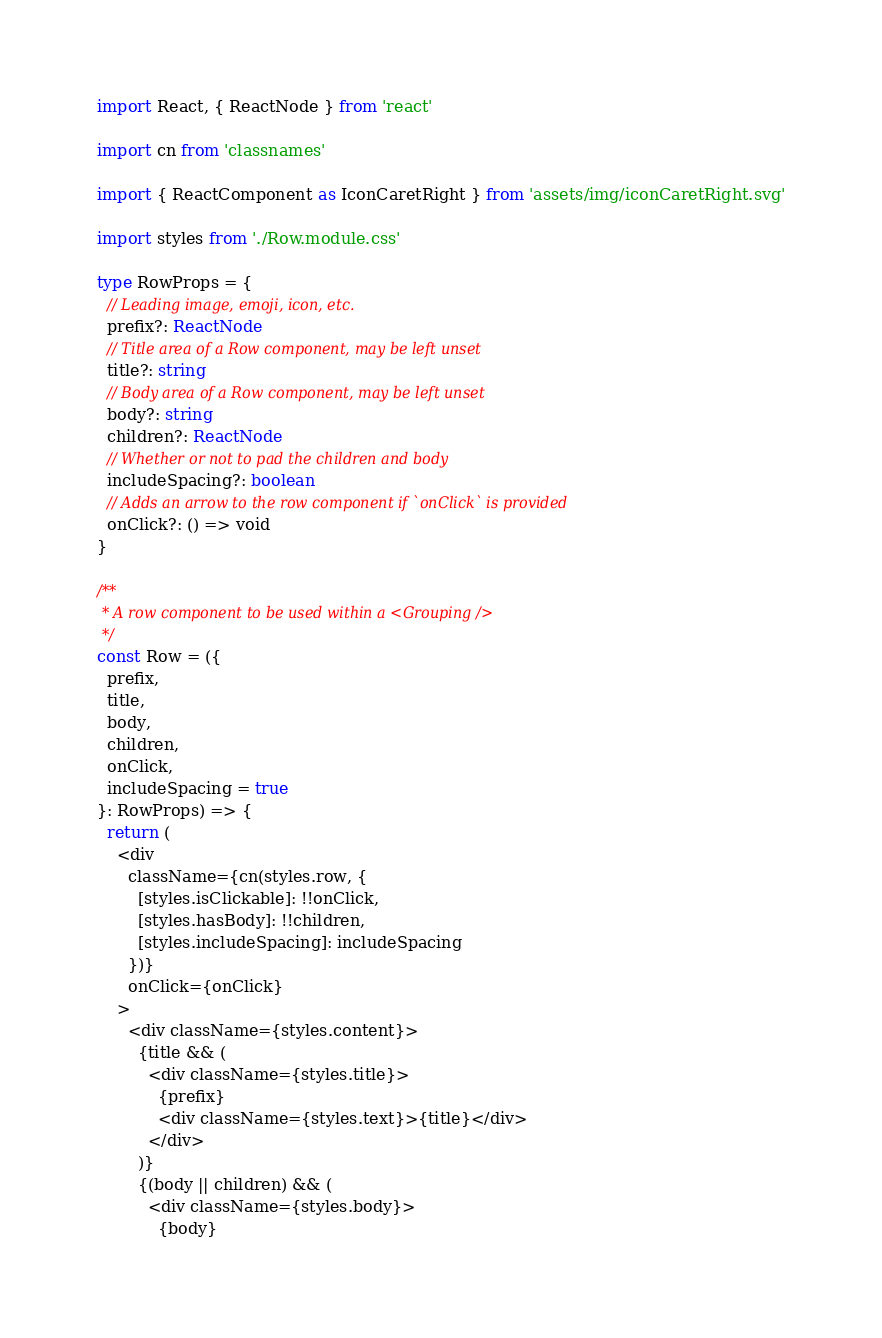<code> <loc_0><loc_0><loc_500><loc_500><_TypeScript_>import React, { ReactNode } from 'react'

import cn from 'classnames'

import { ReactComponent as IconCaretRight } from 'assets/img/iconCaretRight.svg'

import styles from './Row.module.css'

type RowProps = {
  // Leading image, emoji, icon, etc.
  prefix?: ReactNode
  // Title area of a Row component, may be left unset
  title?: string
  // Body area of a Row component, may be left unset
  body?: string
  children?: ReactNode
  // Whether or not to pad the children and body
  includeSpacing?: boolean
  // Adds an arrow to the row component if `onClick` is provided
  onClick?: () => void
}

/**
 * A row component to be used within a <Grouping />
 */
const Row = ({
  prefix,
  title,
  body,
  children,
  onClick,
  includeSpacing = true
}: RowProps) => {
  return (
    <div
      className={cn(styles.row, {
        [styles.isClickable]: !!onClick,
        [styles.hasBody]: !!children,
        [styles.includeSpacing]: includeSpacing
      })}
      onClick={onClick}
    >
      <div className={styles.content}>
        {title && (
          <div className={styles.title}>
            {prefix}
            <div className={styles.text}>{title}</div>
          </div>
        )}
        {(body || children) && (
          <div className={styles.body}>
            {body}</code> 